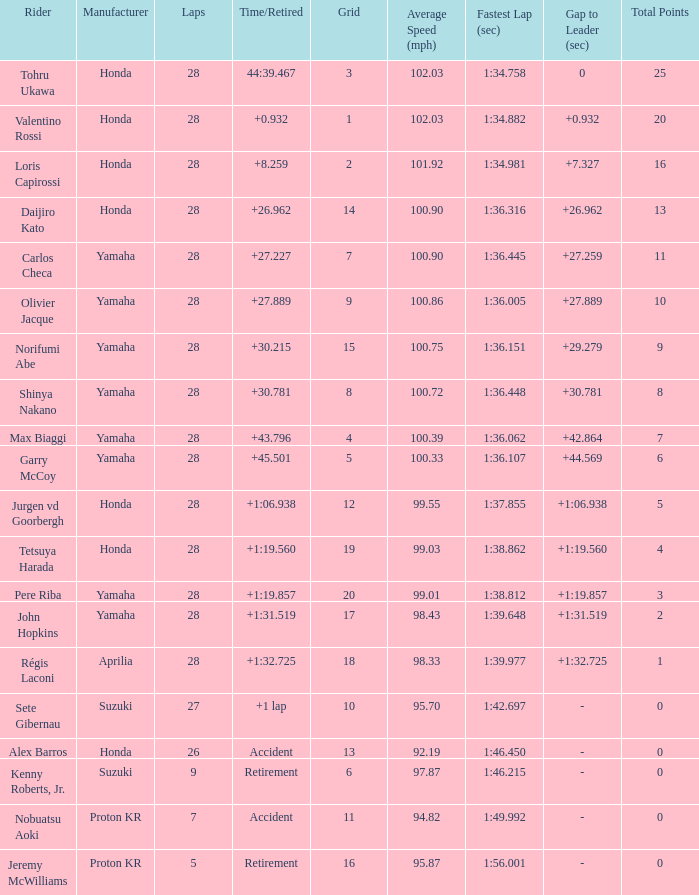Which Grid has Laps larger than 26, and a Time/Retired of 44:39.467? 3.0. 